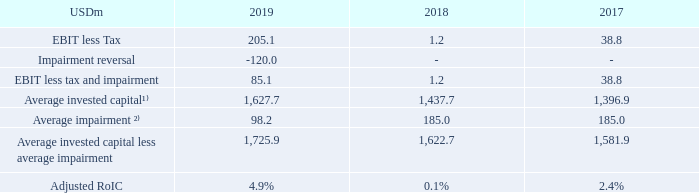Adjusted Return on Invested Capital (Adjusted RoIC): TORM defines Adjusted RoIC as earnings before interest and tax (EBIT) less tax and impairment losses and reversals, divided by the average invested capital less average impairment for the period. Invested capital is defined below.
The Adjusted RoIC expresses the returns generated on capital invested in the Group adjusted for impacts related to the impairment of the fleet. The progression of RoIC is used by TORM to measure progress against our longer-term value creation goals outlined to investors. Adjusted RoIC is calculated as follows:
¹⁾ Average invested capital is calculated as the average of the opening and closing balance of invested capital.
²⁾ Average impairment is calculated as the average of the opening and closing balances of impairment charges on vessels and goodwill in the balance sheet.
How is average invested capital calculated? As the average of the opening and closing balance of invested capital. How is average impairment calculated? As the average of the opening and closing balances of impairment charges on vessels and goodwill in the balance sheet. For which years is the adjusted RoIC calculated in the table? 2019, 2018, 2017. In which year was the Average invested capital less average impairment the largest? 1,725.9>1,622.7>1,581.9
Answer: 2019. What was the change in the Average invested capital less average impairment in 2019 from 2018?
Answer scale should be: million. 1,725.9-1,622.7
Answer: 103.2. What was the percentage change in the Average invested capital less average impairment in 2019 from 2018?
Answer scale should be: percent. (1,725.9-1,622.7)/1,622.7
Answer: 6.36. 